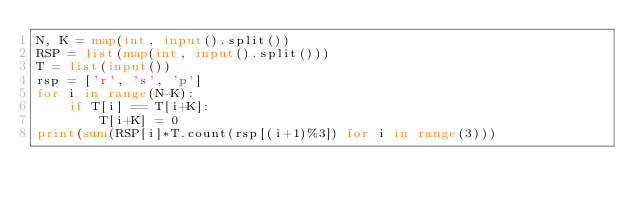<code> <loc_0><loc_0><loc_500><loc_500><_Python_>N, K = map(int, input().split())
RSP = list(map(int, input().split()))
T = list(input())
rsp = ['r', 's', 'p']
for i in range(N-K):
    if T[i] == T[i+K]:
        T[i+K] = 0
print(sum(RSP[i]*T.count(rsp[(i+1)%3]) for i in range(3)))
</code> 